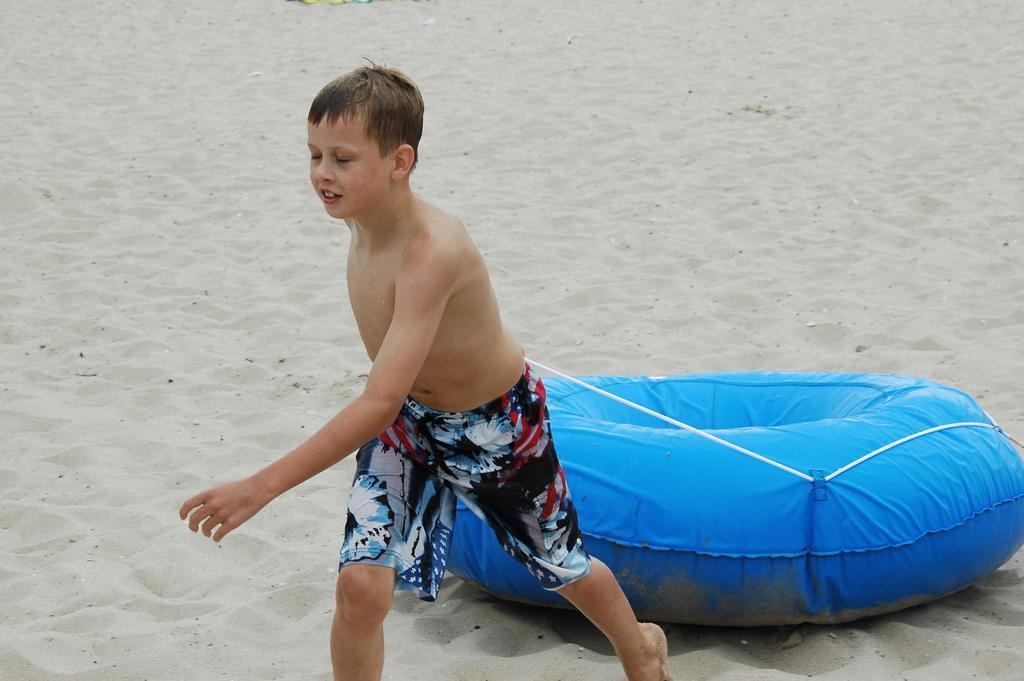Describe this image in one or two sentences. In this image in the front there is a boy holding an object which is blue in colour. In the background there is sand on the ground. 